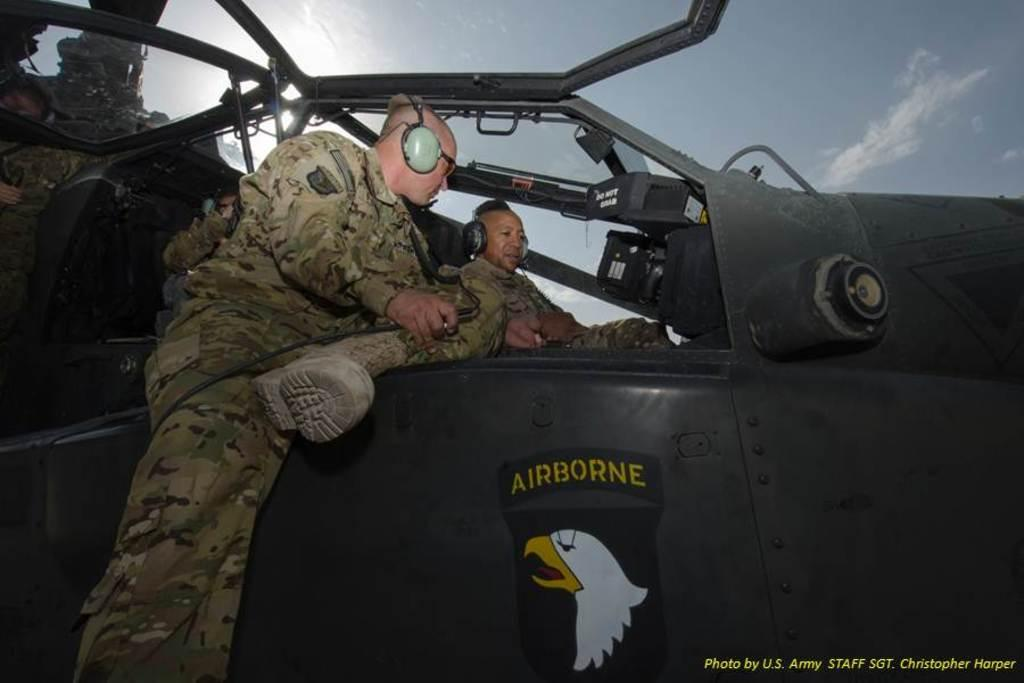<image>
Offer a succinct explanation of the picture presented. two men in a plane cockpit with Airborne on the side 